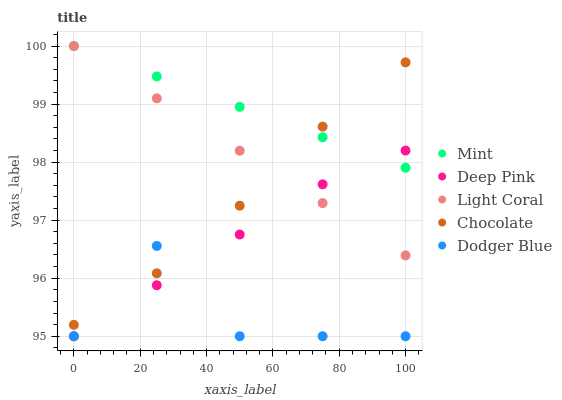Does Dodger Blue have the minimum area under the curve?
Answer yes or no. Yes. Does Mint have the maximum area under the curve?
Answer yes or no. Yes. Does Deep Pink have the minimum area under the curve?
Answer yes or no. No. Does Deep Pink have the maximum area under the curve?
Answer yes or no. No. Is Mint the smoothest?
Answer yes or no. Yes. Is Dodger Blue the roughest?
Answer yes or no. Yes. Is Deep Pink the smoothest?
Answer yes or no. No. Is Deep Pink the roughest?
Answer yes or no. No. Does Dodger Blue have the lowest value?
Answer yes or no. Yes. Does Mint have the lowest value?
Answer yes or no. No. Does Mint have the highest value?
Answer yes or no. Yes. Does Deep Pink have the highest value?
Answer yes or no. No. Is Deep Pink less than Chocolate?
Answer yes or no. Yes. Is Light Coral greater than Dodger Blue?
Answer yes or no. Yes. Does Dodger Blue intersect Chocolate?
Answer yes or no. Yes. Is Dodger Blue less than Chocolate?
Answer yes or no. No. Is Dodger Blue greater than Chocolate?
Answer yes or no. No. Does Deep Pink intersect Chocolate?
Answer yes or no. No. 